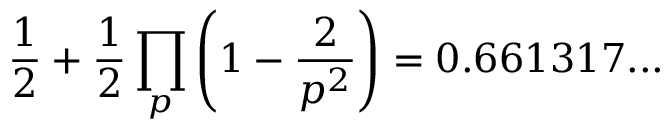<formula> <loc_0><loc_0><loc_500><loc_500>{ \frac { 1 } { 2 } } + { \frac { 1 } { 2 } } \prod _ { p } \left ( 1 - { \frac { 2 } { p ^ { 2 } } } \right ) = 0 . 6 6 1 3 1 7 \dots</formula> 